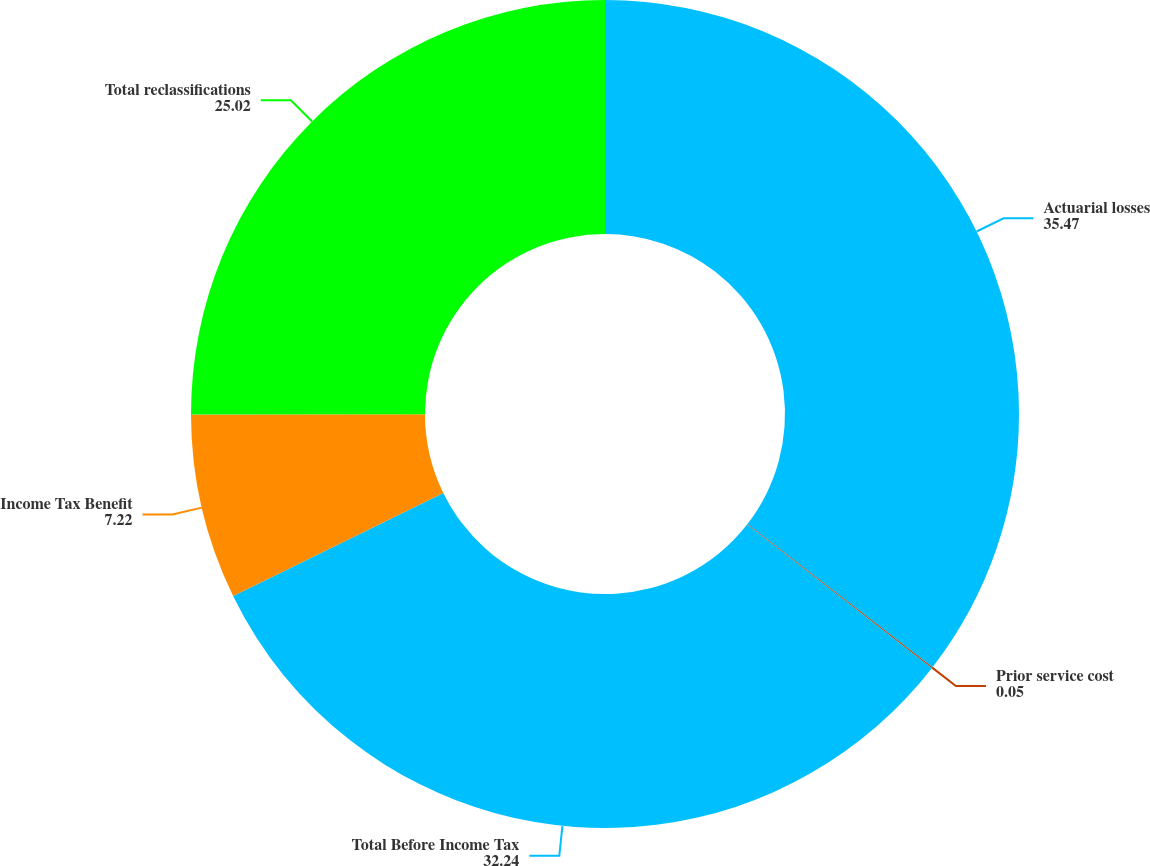Convert chart. <chart><loc_0><loc_0><loc_500><loc_500><pie_chart><fcel>Actuarial losses<fcel>Prior service cost<fcel>Total Before Income Tax<fcel>Income Tax Benefit<fcel>Total reclassifications<nl><fcel>35.47%<fcel>0.05%<fcel>32.24%<fcel>7.22%<fcel>25.02%<nl></chart> 